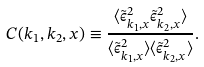Convert formula to latex. <formula><loc_0><loc_0><loc_500><loc_500>C ( k _ { 1 } , k _ { 2 } , x ) \equiv \frac { \langle \tilde { \epsilon } ^ { 2 } _ { k _ { 1 } , x } \tilde { \epsilon } ^ { 2 } _ { k _ { 2 } , x } \rangle } { \langle \tilde { \epsilon } ^ { 2 } _ { k _ { 1 } , x } \rangle \langle \tilde { \epsilon } ^ { 2 } _ { k _ { 2 } , x } \rangle } .</formula> 